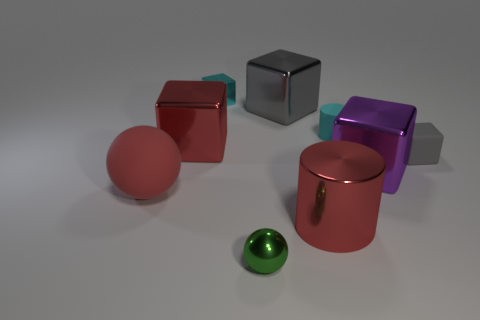Is there another small object of the same shape as the tiny cyan rubber thing?
Keep it short and to the point. No. Is the number of small green shiny cylinders less than the number of large red metallic cylinders?
Give a very brief answer. Yes. Do the tiny cyan metal thing and the large gray metal thing have the same shape?
Offer a terse response. Yes. What number of objects are either tiny green objects or shiny blocks on the left side of the large purple metallic cube?
Make the answer very short. 4. How many cubes are there?
Offer a terse response. 5. Are there any brown cylinders of the same size as the cyan cylinder?
Your answer should be compact. No. Is the number of large red matte spheres behind the small cyan matte cylinder less than the number of tiny gray things?
Provide a short and direct response. Yes. Do the shiny sphere and the cyan shiny thing have the same size?
Offer a very short reply. Yes. What size is the ball that is made of the same material as the tiny cylinder?
Your response must be concise. Large. How many other rubber cylinders have the same color as the small rubber cylinder?
Provide a succinct answer. 0. 